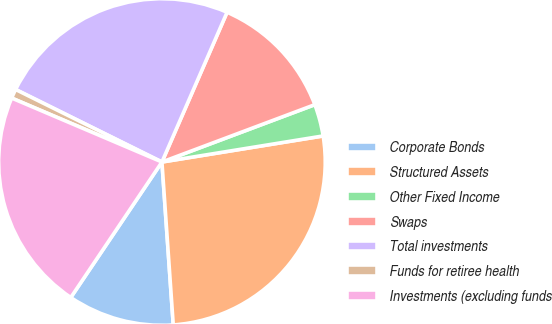Convert chart to OTSL. <chart><loc_0><loc_0><loc_500><loc_500><pie_chart><fcel>Corporate Bonds<fcel>Structured Assets<fcel>Other Fixed Income<fcel>Swaps<fcel>Total investments<fcel>Funds for retiree health<fcel>Investments (excluding funds<nl><fcel>10.53%<fcel>26.45%<fcel>3.16%<fcel>12.76%<fcel>24.21%<fcel>0.92%<fcel>21.98%<nl></chart> 